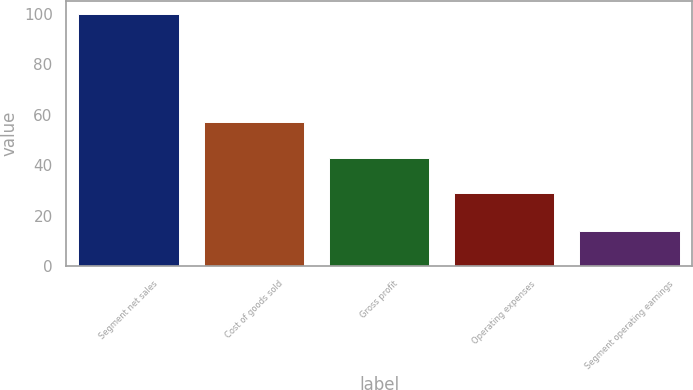<chart> <loc_0><loc_0><loc_500><loc_500><bar_chart><fcel>Segment net sales<fcel>Cost of goods sold<fcel>Gross profit<fcel>Operating expenses<fcel>Segment operating earnings<nl><fcel>100<fcel>57.3<fcel>42.7<fcel>28.8<fcel>13.9<nl></chart> 